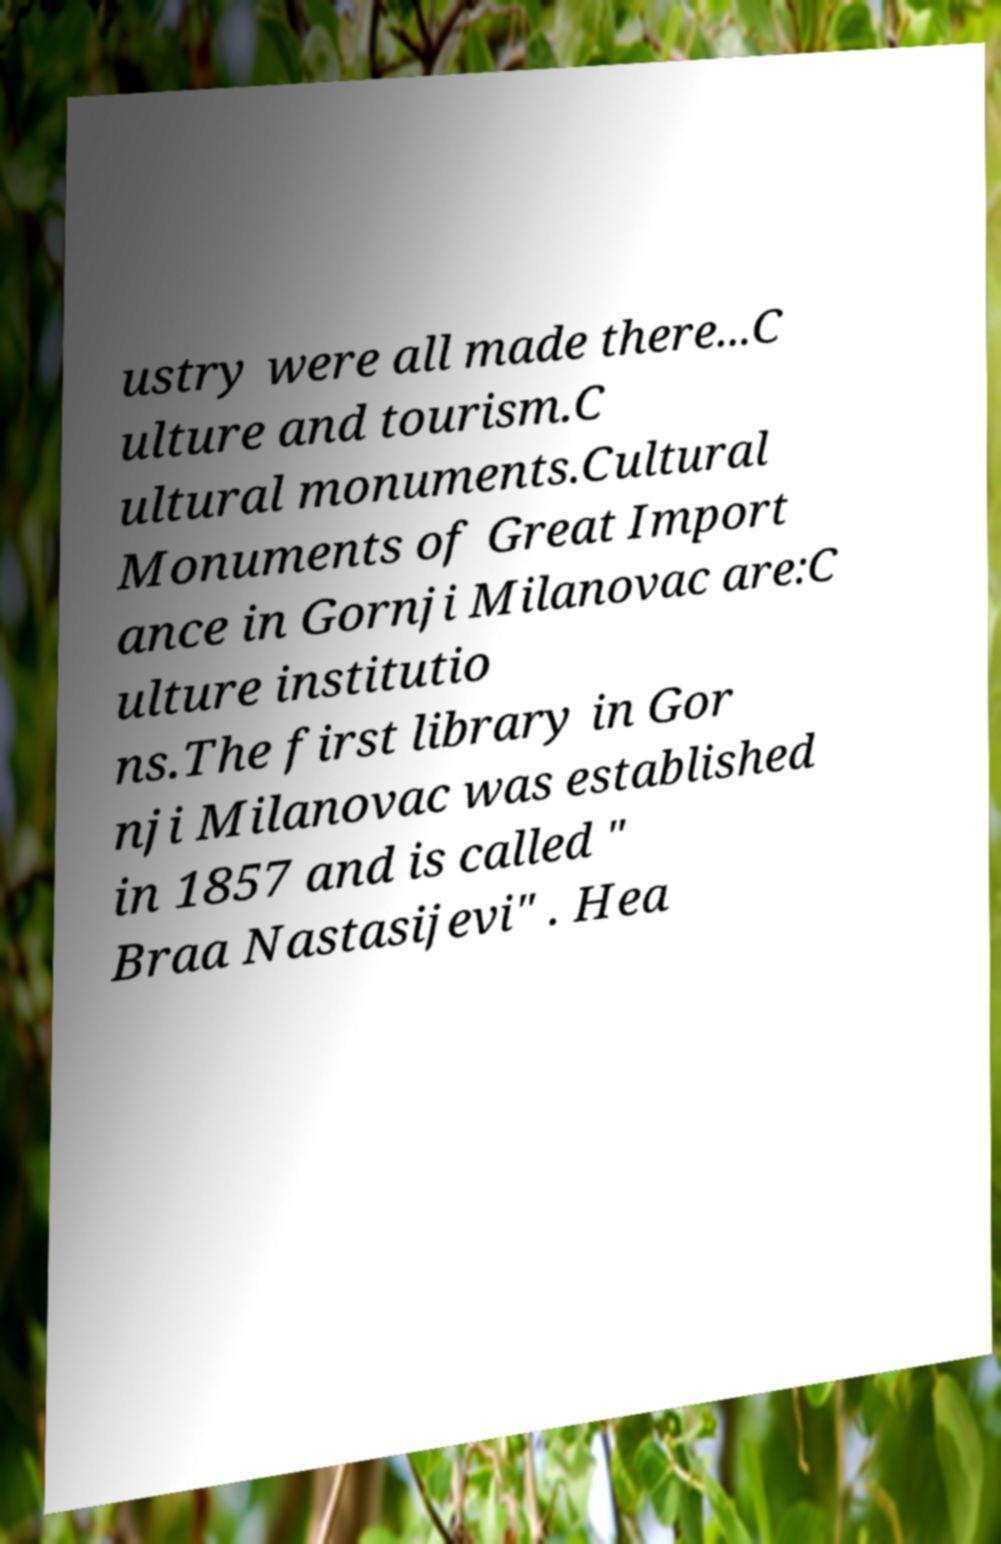For documentation purposes, I need the text within this image transcribed. Could you provide that? ustry were all made there...C ulture and tourism.C ultural monuments.Cultural Monuments of Great Import ance in Gornji Milanovac are:C ulture institutio ns.The first library in Gor nji Milanovac was established in 1857 and is called " Braa Nastasijevi" . Hea 